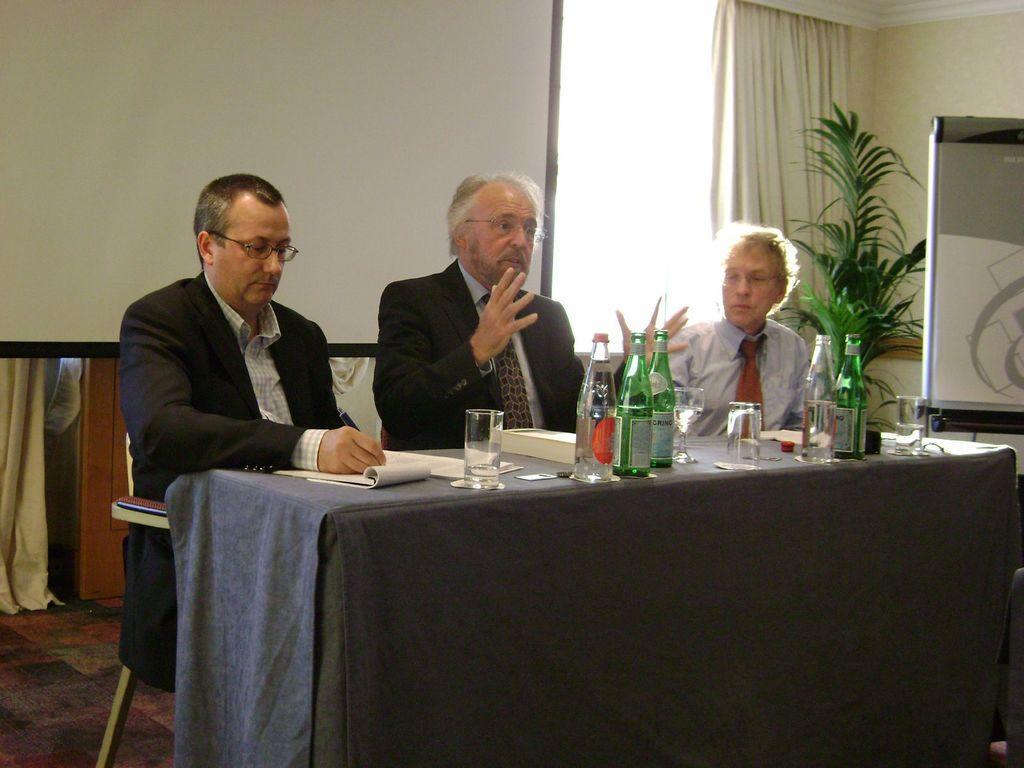How would you summarize this image in a sentence or two? In this image i can see a three persons sit in front a table. on the table there are the bottles and glass kept on that and books and papers kept on the table ,on the right side i can see a flower pot , and back side of the plan t there is a curtain and there is a wall visible. 